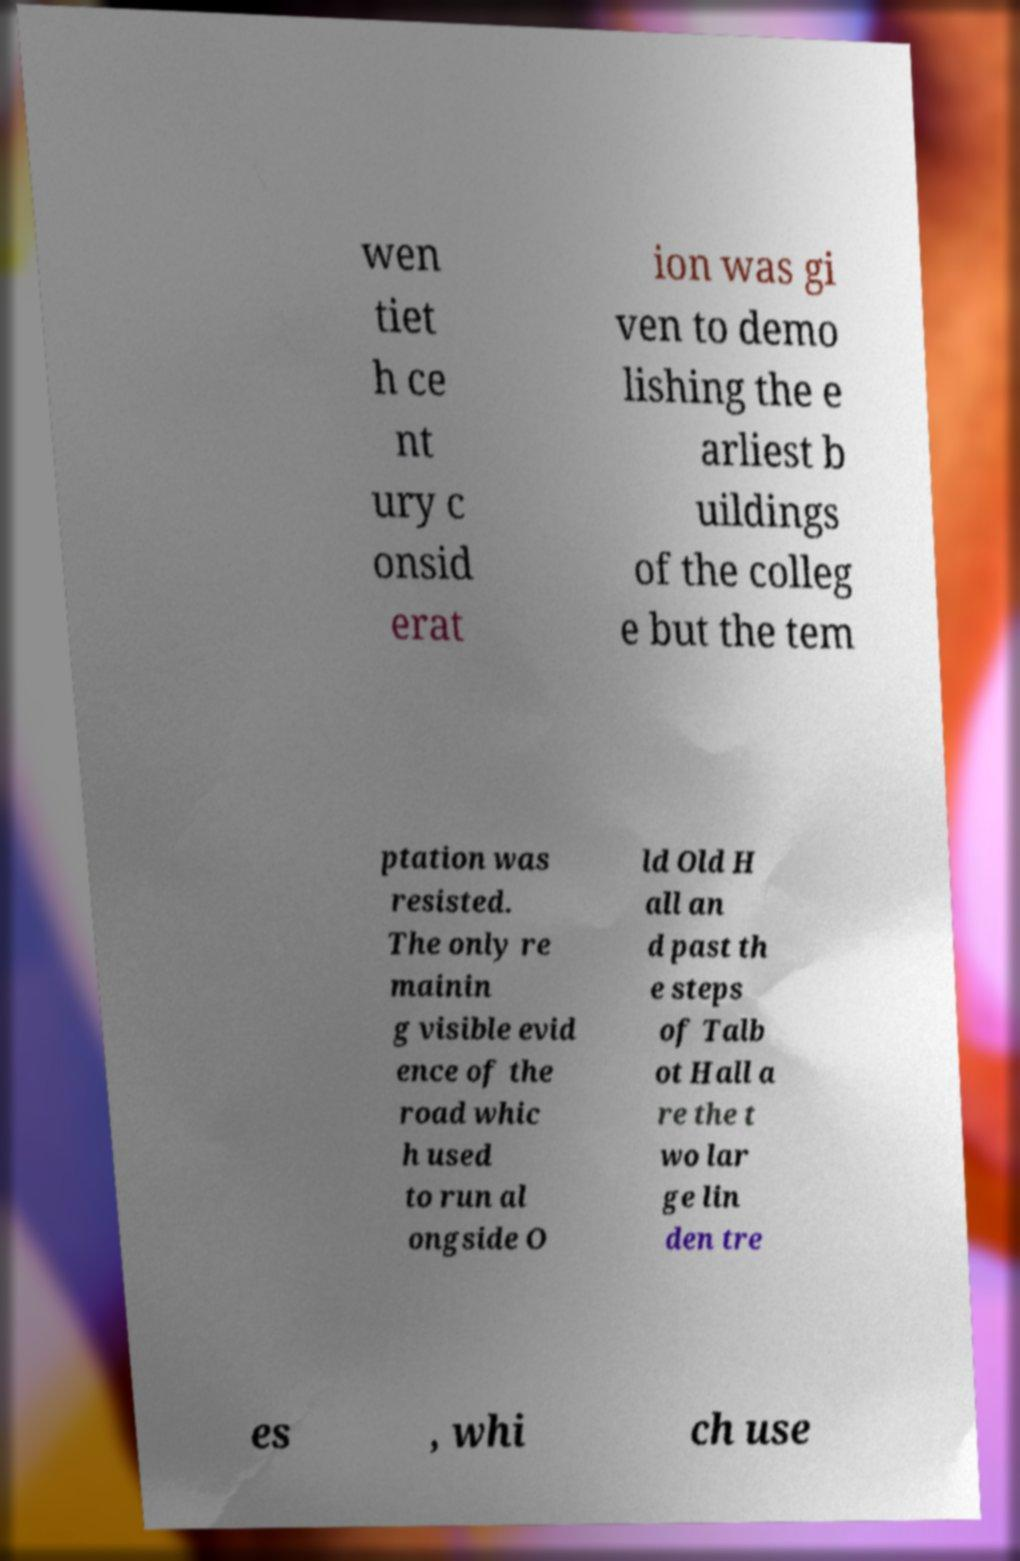What messages or text are displayed in this image? I need them in a readable, typed format. wen tiet h ce nt ury c onsid erat ion was gi ven to demo lishing the e arliest b uildings of the colleg e but the tem ptation was resisted. The only re mainin g visible evid ence of the road whic h used to run al ongside O ld Old H all an d past th e steps of Talb ot Hall a re the t wo lar ge lin den tre es , whi ch use 